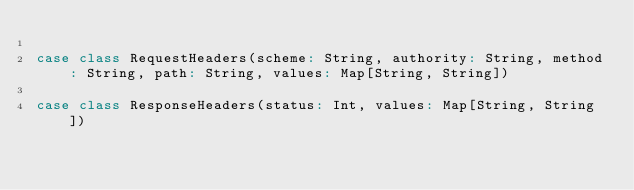Convert code to text. <code><loc_0><loc_0><loc_500><loc_500><_Scala_>
case class RequestHeaders(scheme: String, authority: String, method: String, path: String, values: Map[String, String])

case class ResponseHeaders(status: Int, values: Map[String, String])
</code> 